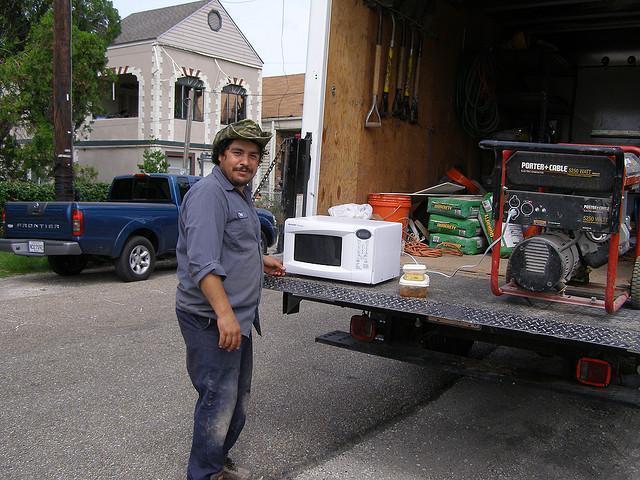How many horses are in the truck?
Give a very brief answer. 0. How many trucks are there?
Give a very brief answer. 2. 